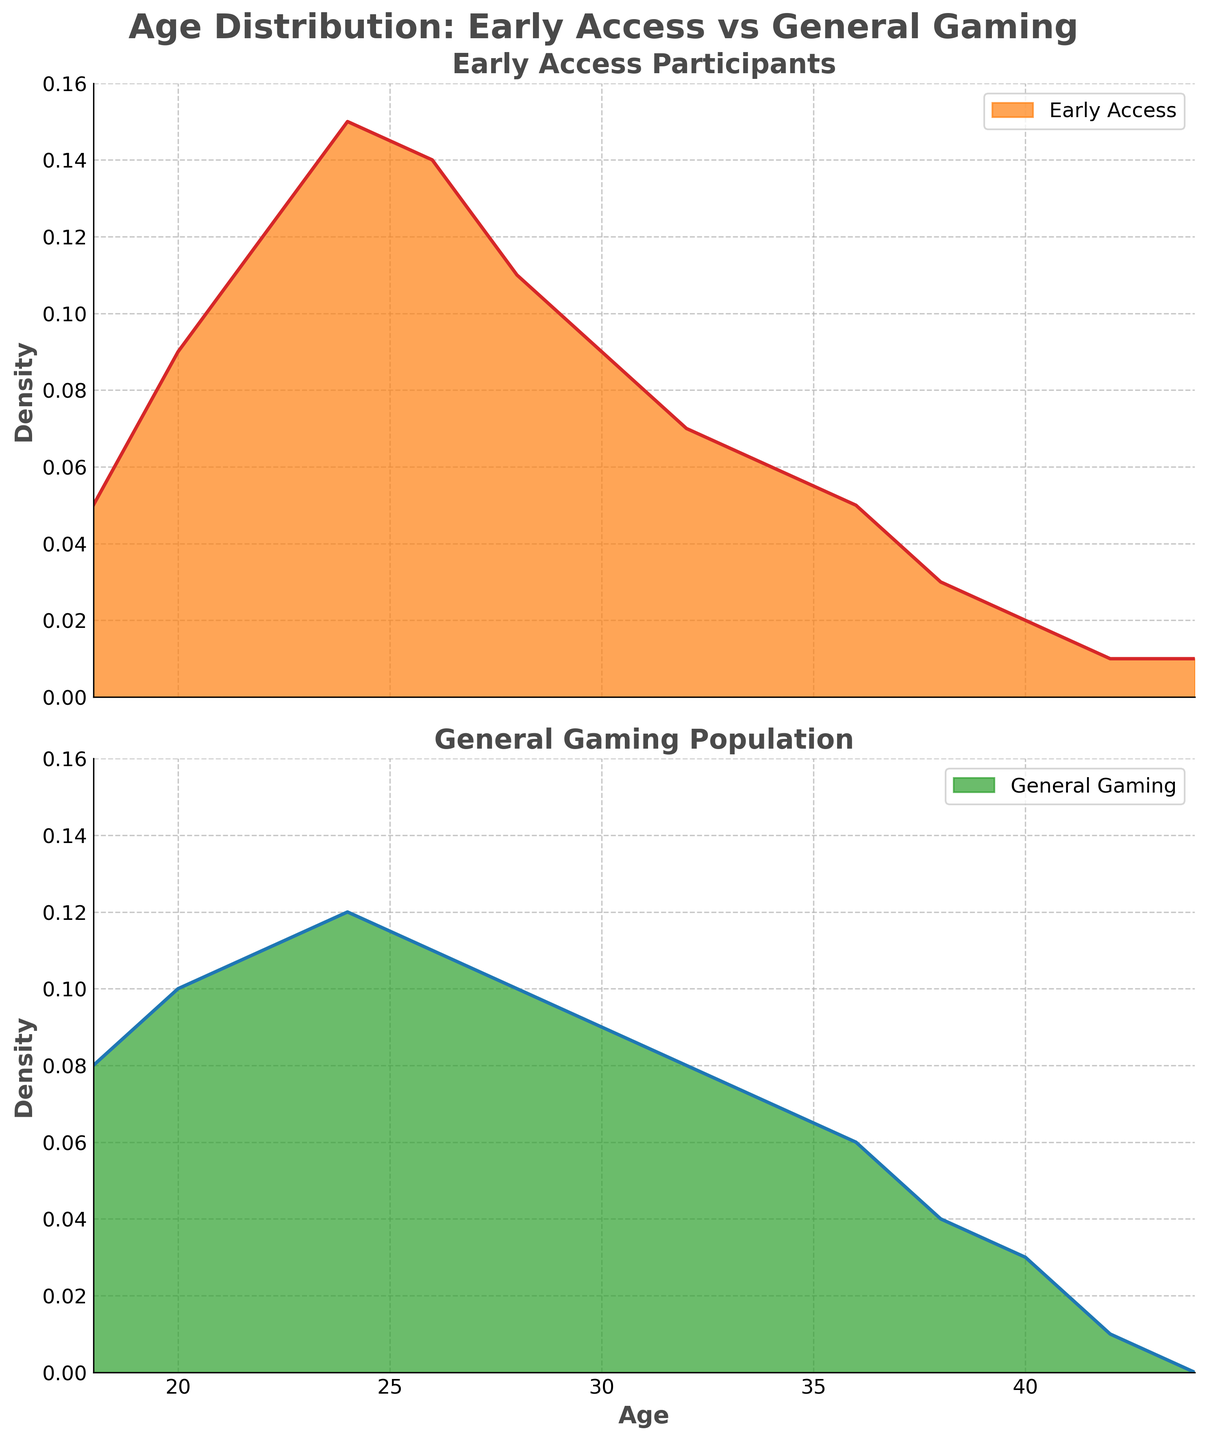What's the title of the figure? The title is placed at the top of the figure and is "Age Distribution: Early Access vs General Gaming".
Answer: Age Distribution: Early Access vs General Gaming What are the x-axis and y-axis labels for both subplots? The x-axis is labeled 'Age' and the y-axis is labeled 'Density' on both subplots. These labels are placed on the respective axes.
Answer: Age, Density Which age group has the highest density in the Early Access group? The highest density for the Early Access group is at age 24. This can be identified by finding the peak of the density plot in the first subplot.
Answer: Age 24 Compare the density of 30-year-olds in both groups. Which group has a higher density and by how much? For 30-year-olds, the density in the Early Access group is 0.09, and in the General Gaming group, it is also 0.09. The densities are equal.
Answer: Both are equal What's the difference in density between Early Access and General Gaming at age 24? The density at age 24 for the Early Access group is 0.15, and for the General Gaming group, it is 0.12. The difference is calculated by subtracting 0.12 from 0.15.
Answer: 0.03 At what ages do both groups have the same density? Both groups have the same density at ages 30 and potentially close at some endpoints, indicated by overlapping densities at these ages in the plots.
Answer: Age 30 Do the Early Access participants generally have a higher or lower density than the General Gaming population in the age range of 20-28? Within the age range of 20-28, the Early Access group generally has a higher density than the General Gaming group, evidenced by the Early Access density curve consistently being above the General Gaming density curve.
Answer: Higher What is the shape of the density distribution for General Gaming around the age of 40? Around age 40, the density distribution for General Gaming decreases gradually, forming a downward slope.
Answer: Downward slope Which group has more participants in their early 20s? In the early 20s (ages 20-24), the Early Access group has more participants, indicated by the higher density values in this range compared to the General Gaming group.
Answer: Early Access group 